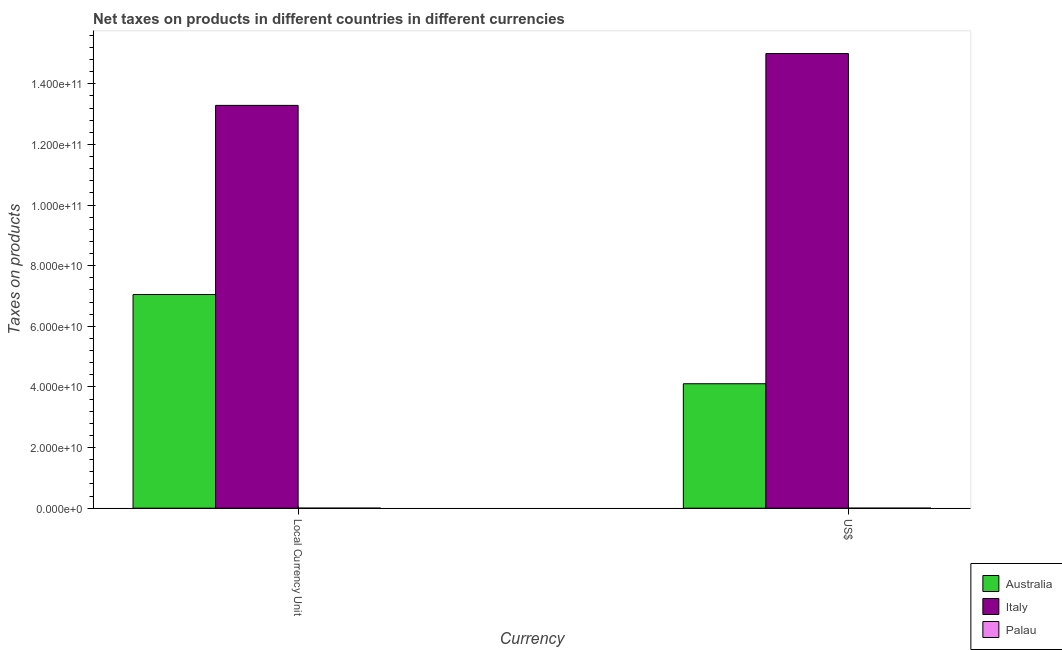How many different coloured bars are there?
Offer a very short reply. 3. How many bars are there on the 2nd tick from the left?
Offer a terse response. 3. How many bars are there on the 2nd tick from the right?
Your answer should be compact. 3. What is the label of the 1st group of bars from the left?
Provide a short and direct response. Local Currency Unit. What is the net taxes in constant 2005 us$ in Australia?
Ensure brevity in your answer.  7.05e+1. Across all countries, what is the maximum net taxes in us$?
Ensure brevity in your answer.  1.50e+11. Across all countries, what is the minimum net taxes in constant 2005 us$?
Offer a very short reply. 1.38e+07. In which country was the net taxes in constant 2005 us$ minimum?
Offer a terse response. Palau. What is the total net taxes in us$ in the graph?
Your response must be concise. 1.91e+11. What is the difference between the net taxes in constant 2005 us$ in Italy and that in Palau?
Give a very brief answer. 1.33e+11. What is the difference between the net taxes in constant 2005 us$ in Palau and the net taxes in us$ in Italy?
Your answer should be compact. -1.50e+11. What is the average net taxes in us$ per country?
Provide a short and direct response. 6.37e+1. What is the difference between the net taxes in us$ and net taxes in constant 2005 us$ in Palau?
Offer a terse response. 0. What is the ratio of the net taxes in us$ in Australia to that in Palau?
Provide a short and direct response. 2967.37. Is the net taxes in constant 2005 us$ in Australia less than that in Palau?
Offer a terse response. No. How many bars are there?
Your answer should be compact. 6. Are all the bars in the graph horizontal?
Make the answer very short. No. How many countries are there in the graph?
Keep it short and to the point. 3. Does the graph contain any zero values?
Your answer should be compact. No. Does the graph contain grids?
Provide a short and direct response. No. Where does the legend appear in the graph?
Give a very brief answer. Bottom right. What is the title of the graph?
Your answer should be very brief. Net taxes on products in different countries in different currencies. What is the label or title of the X-axis?
Keep it short and to the point. Currency. What is the label or title of the Y-axis?
Your response must be concise. Taxes on products. What is the Taxes on products of Australia in Local Currency Unit?
Your answer should be compact. 7.05e+1. What is the Taxes on products in Italy in Local Currency Unit?
Your answer should be compact. 1.33e+11. What is the Taxes on products in Palau in Local Currency Unit?
Give a very brief answer. 1.38e+07. What is the Taxes on products in Australia in US$?
Your response must be concise. 4.10e+1. What is the Taxes on products of Italy in US$?
Give a very brief answer. 1.50e+11. What is the Taxes on products in Palau in US$?
Provide a succinct answer. 1.38e+07. Across all Currency, what is the maximum Taxes on products in Australia?
Ensure brevity in your answer.  7.05e+1. Across all Currency, what is the maximum Taxes on products in Italy?
Give a very brief answer. 1.50e+11. Across all Currency, what is the maximum Taxes on products of Palau?
Ensure brevity in your answer.  1.38e+07. Across all Currency, what is the minimum Taxes on products in Australia?
Provide a short and direct response. 4.10e+1. Across all Currency, what is the minimum Taxes on products in Italy?
Keep it short and to the point. 1.33e+11. Across all Currency, what is the minimum Taxes on products of Palau?
Offer a very short reply. 1.38e+07. What is the total Taxes on products in Australia in the graph?
Your response must be concise. 1.12e+11. What is the total Taxes on products in Italy in the graph?
Your answer should be compact. 2.83e+11. What is the total Taxes on products of Palau in the graph?
Provide a succinct answer. 2.77e+07. What is the difference between the Taxes on products in Australia in Local Currency Unit and that in US$?
Your response must be concise. 2.94e+1. What is the difference between the Taxes on products in Italy in Local Currency Unit and that in US$?
Provide a short and direct response. -1.71e+1. What is the difference between the Taxes on products in Australia in Local Currency Unit and the Taxes on products in Italy in US$?
Provide a short and direct response. -7.95e+1. What is the difference between the Taxes on products of Australia in Local Currency Unit and the Taxes on products of Palau in US$?
Your answer should be compact. 7.05e+1. What is the difference between the Taxes on products in Italy in Local Currency Unit and the Taxes on products in Palau in US$?
Your response must be concise. 1.33e+11. What is the average Taxes on products of Australia per Currency?
Your answer should be very brief. 5.58e+1. What is the average Taxes on products of Italy per Currency?
Provide a short and direct response. 1.41e+11. What is the average Taxes on products in Palau per Currency?
Offer a very short reply. 1.38e+07. What is the difference between the Taxes on products in Australia and Taxes on products in Italy in Local Currency Unit?
Your response must be concise. -6.24e+1. What is the difference between the Taxes on products of Australia and Taxes on products of Palau in Local Currency Unit?
Give a very brief answer. 7.05e+1. What is the difference between the Taxes on products in Italy and Taxes on products in Palau in Local Currency Unit?
Your answer should be very brief. 1.33e+11. What is the difference between the Taxes on products in Australia and Taxes on products in Italy in US$?
Your answer should be compact. -1.09e+11. What is the difference between the Taxes on products in Australia and Taxes on products in Palau in US$?
Provide a short and direct response. 4.10e+1. What is the difference between the Taxes on products in Italy and Taxes on products in Palau in US$?
Keep it short and to the point. 1.50e+11. What is the ratio of the Taxes on products of Australia in Local Currency Unit to that in US$?
Keep it short and to the point. 1.72. What is the ratio of the Taxes on products in Italy in Local Currency Unit to that in US$?
Provide a succinct answer. 0.89. What is the ratio of the Taxes on products of Palau in Local Currency Unit to that in US$?
Keep it short and to the point. 1. What is the difference between the highest and the second highest Taxes on products of Australia?
Provide a short and direct response. 2.94e+1. What is the difference between the highest and the second highest Taxes on products of Italy?
Your answer should be very brief. 1.71e+1. What is the difference between the highest and the second highest Taxes on products of Palau?
Offer a terse response. 0. What is the difference between the highest and the lowest Taxes on products in Australia?
Your response must be concise. 2.94e+1. What is the difference between the highest and the lowest Taxes on products in Italy?
Provide a short and direct response. 1.71e+1. What is the difference between the highest and the lowest Taxes on products of Palau?
Ensure brevity in your answer.  0. 